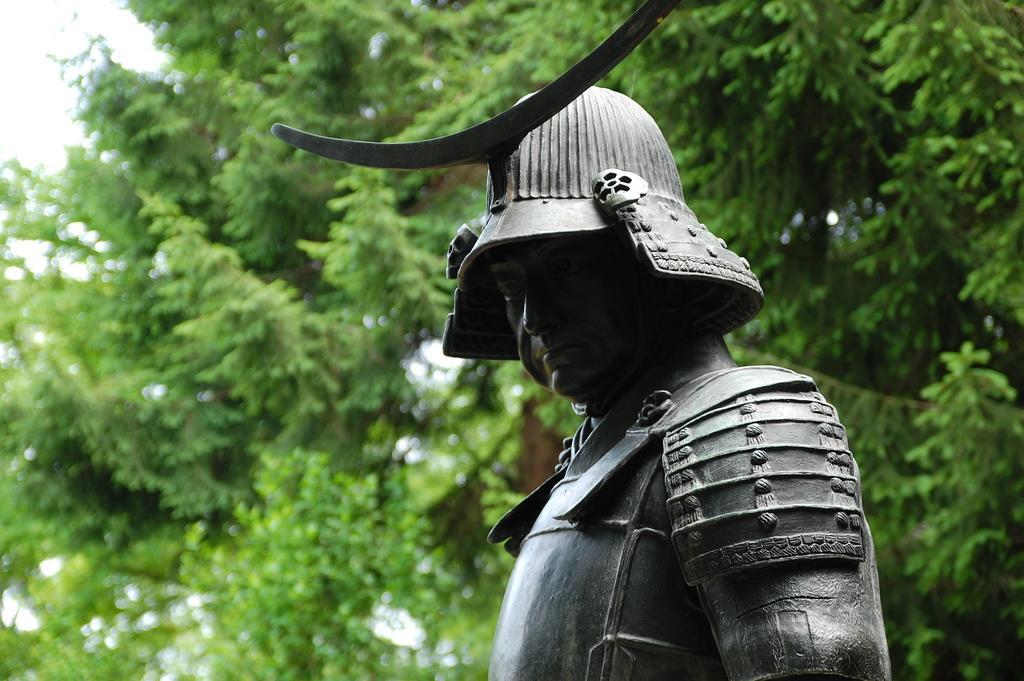Please provide a concise description of this image. This picture is clicked outside. In the foreground we can see the sculpture of a person. In the background we can see the trees. 